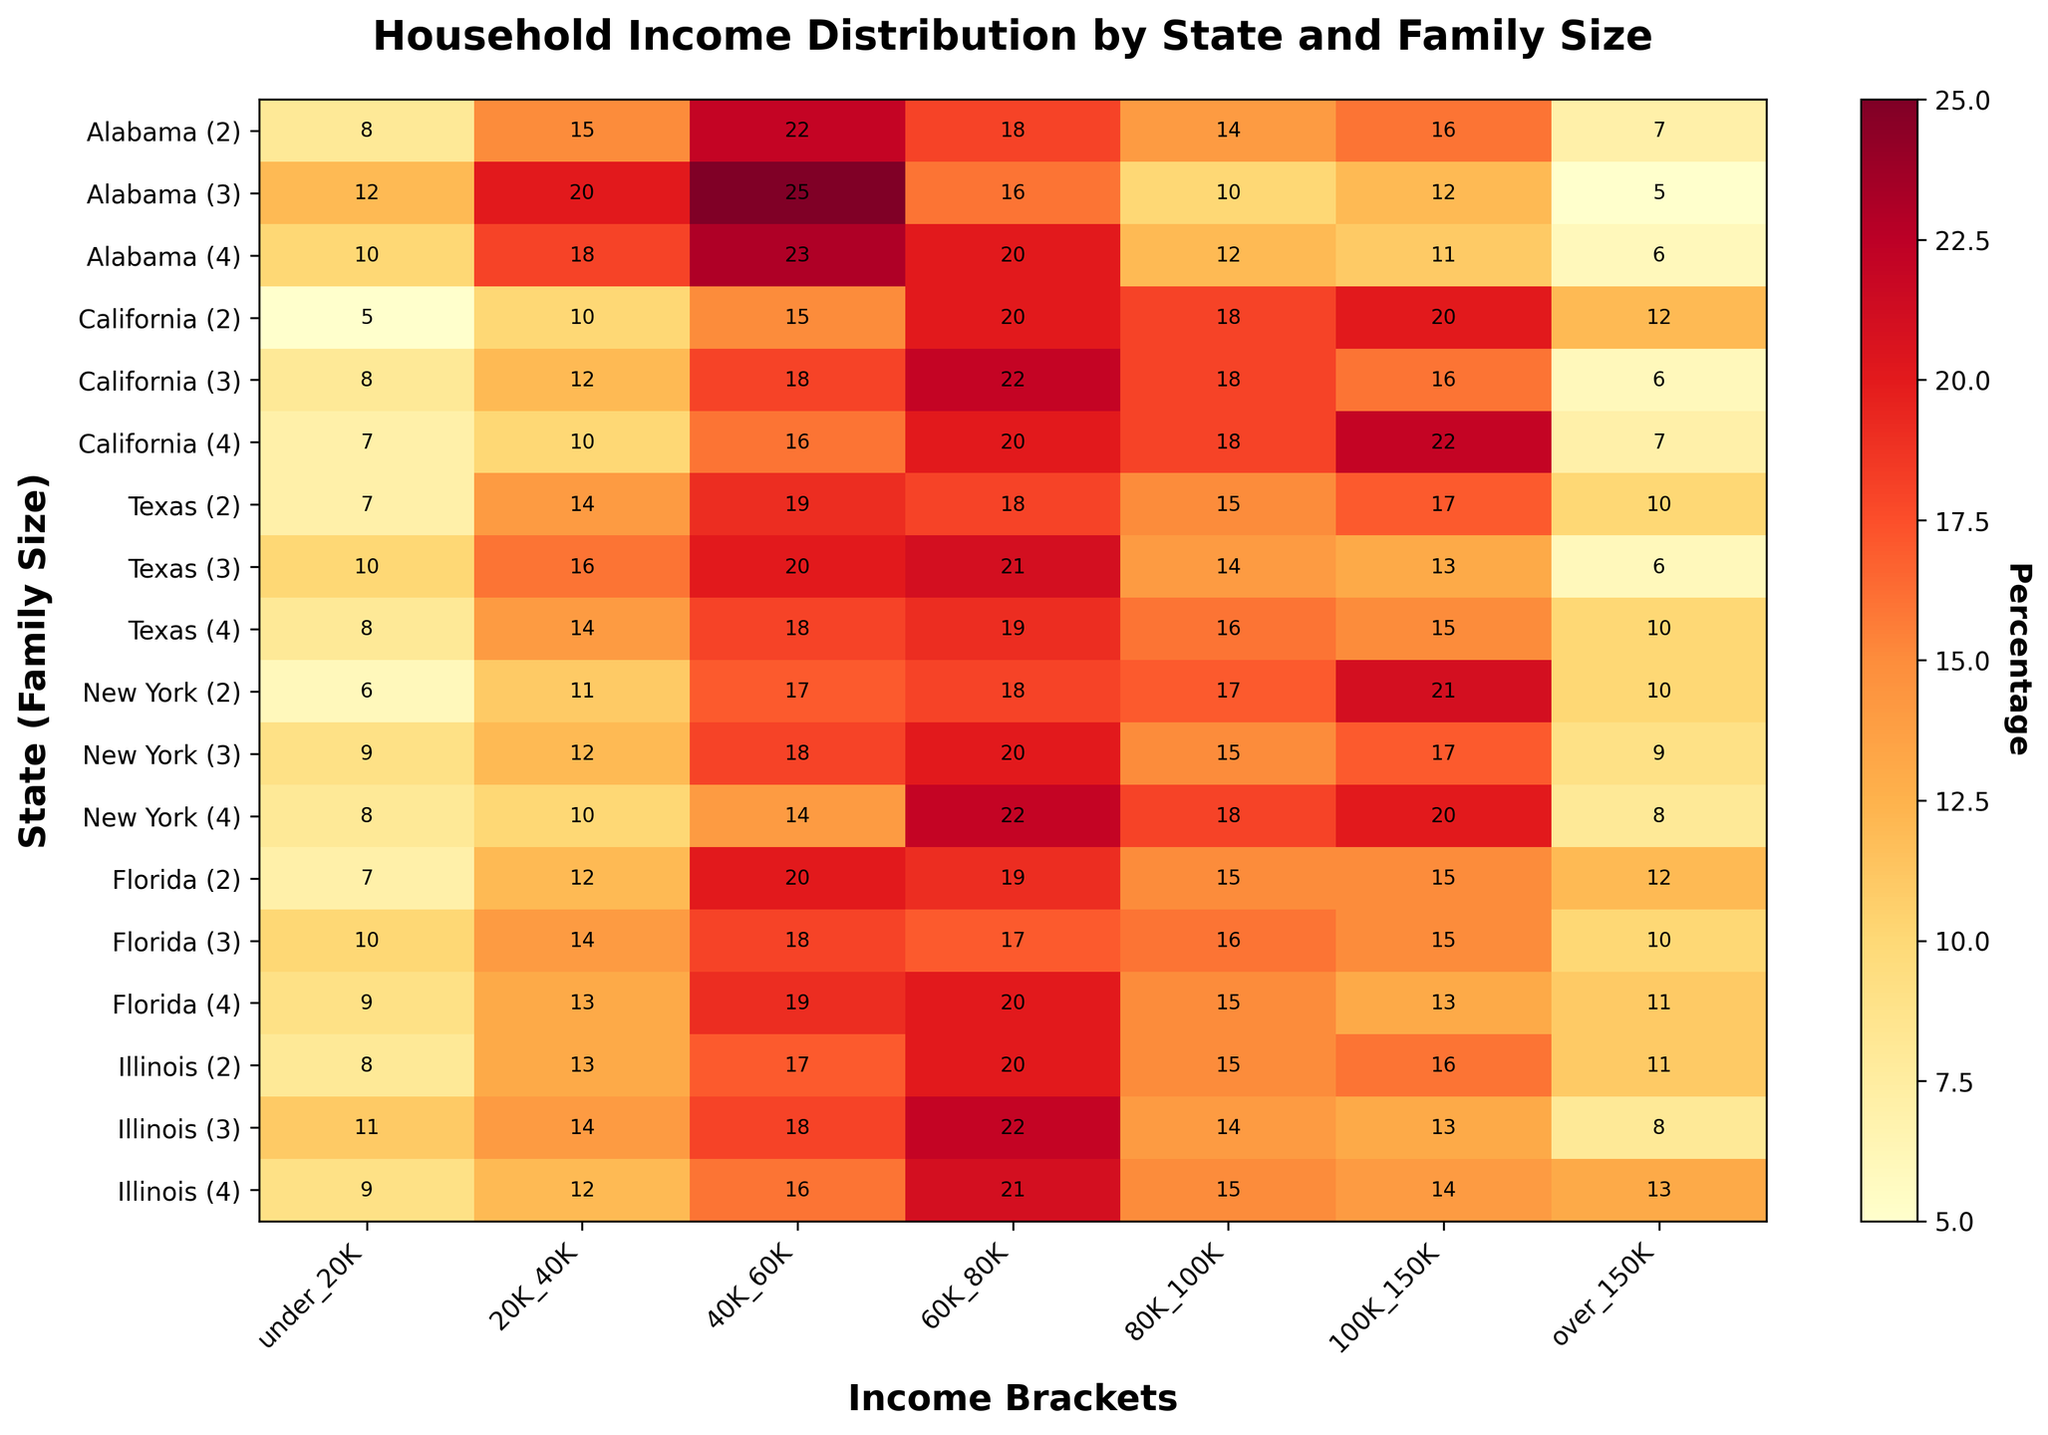What is the title of the heatmap? The title of the heatmap is located at the top center of the figure. It provides a summary of what the heatmap represents in a brief manner.
Answer: Household Income Distribution by State and Family Size How many states are included in the heatmap? The number of states included in the heatmap can be found by counting the unique state names listed on the y-axis.
Answer: 6 What is the income bracket with the highest percentage in California for a family of 4? Locate the row labeled "California (4)" on the y-axis. Look across this row to find the column with the highest value.
Answer: 80K_100K Which income bracket shows the lowest percentage for New York with a family size of 3? Locate the row labeled "New York (3)" on the y-axis. Identify the column with the lowest value in this row.
Answer: under_20K What is the average percentage of families in Texas (family size 3) earning between 40K and 80K? Locate the row labeled "Texas (3)" and find the percentages for the 40K_60K and 60K_80K columns. Average these values: (20 + 21) / 2 = 20.5.
Answer: 20.5 Which state-family combination has the highest percentage for the "over_150K" income bracket? Look down the "over_150K" column to find the highest value. Then identify the corresponding state-family combination on the y-axis.
Answer: California (2) Are there any family sizes in Illinois where the percentage for "under_20K" is higher than for "20K_40K"? For each family size in Illinois, compare the percentages in the "under_20K" and "20K_40K" columns. None of the entries in "under_20K" are higher.
Answer: No Which family size in Florida has the highest percentage of households earning between 60K and 80K? Look at the rows labeled with Florida and find the column "60K_80K." Identify the highest value among family sizes of 2, 3, and 4.
Answer: Family size 4 In Texas, how does the percentage of families of size 4 earning 100K_150K compare to those earning under_20K? Locate the row labeled "Texas (4)" and compare the values in the "100K_150K" and "under_20K" columns: 15 vs. 8.
Answer: 100K_150K is higher What is the average percentage of "over_150K" income bracket across all states for family size 2? Look at the rows for family size 2 in each state and find the "over_150K" column. Average these values (7+12+10+10+12+11) / 6 = 10.3333.
Answer: 10.3333 